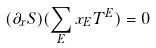Convert formula to latex. <formula><loc_0><loc_0><loc_500><loc_500>( \partial _ { x } S ) ( \sum _ { E } x _ { E } T ^ { E } ) = 0</formula> 